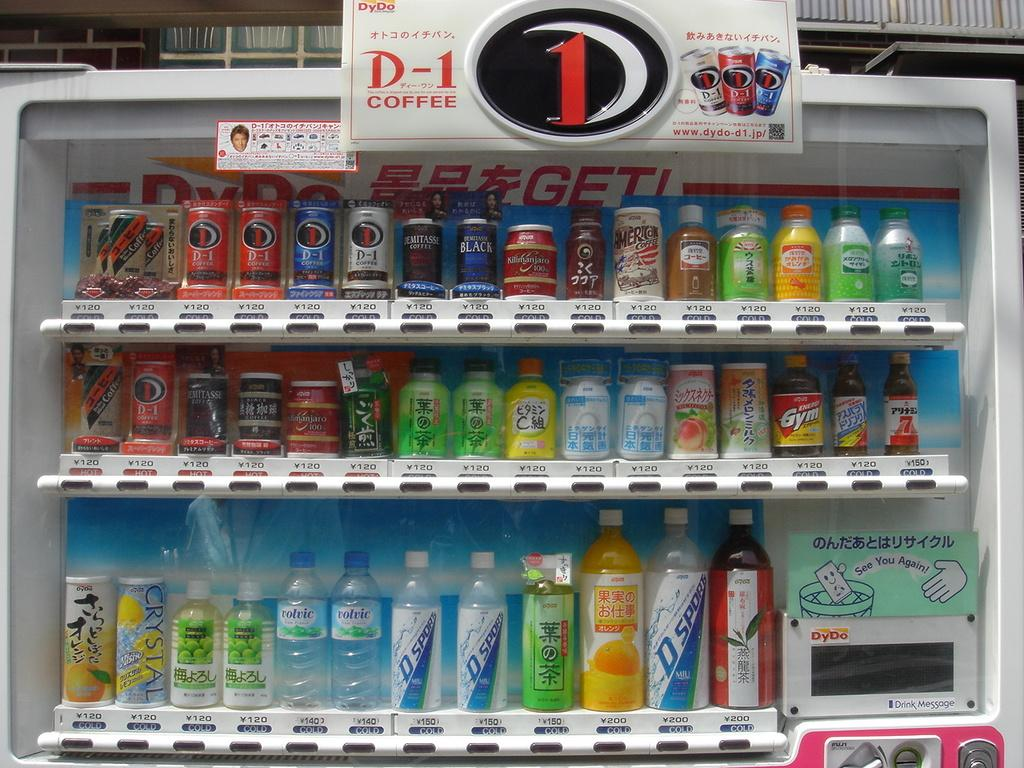Provide a one-sentence caption for the provided image. A collection of drinks include names like Crystal, D-1, and Demitasse. 